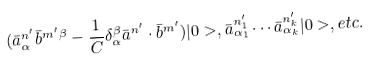Convert formula to latex. <formula><loc_0><loc_0><loc_500><loc_500>( \bar { a } _ { \alpha } ^ { n ^ { \prime } } \bar { b } ^ { m ^ { \prime } \beta } - \frac { 1 } { C } \delta _ { \alpha } ^ { \beta } \bar { a } ^ { n ^ { \prime } } \cdot \bar { b } ^ { m ^ { \prime } } ) | 0 > , \bar { a } _ { \alpha _ { 1 } } ^ { n _ { 1 } ^ { \prime } } \cdots \bar { a } _ { \alpha _ { k } } ^ { n _ { k } ^ { \prime } } | 0 > , e t c .</formula> 